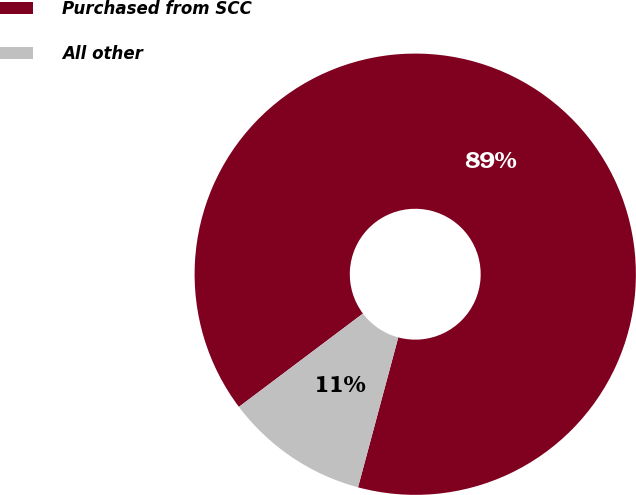Convert chart. <chart><loc_0><loc_0><loc_500><loc_500><pie_chart><fcel>Purchased from SCC<fcel>All other<nl><fcel>89.44%<fcel>10.56%<nl></chart> 